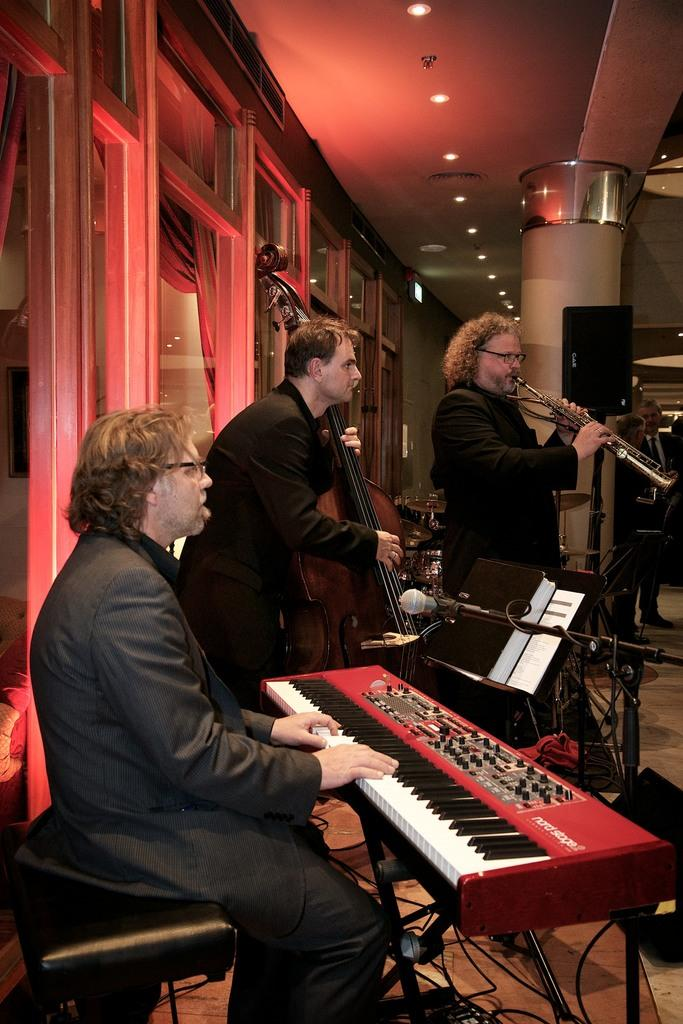How many men are in the image? There are three men in the image. What are the men doing in the image? Each of the men is holding a musical instrument. What can be seen in the background of the image? There are windows, lights on the ceiling, a speaker, and people visible in the background. What type of throne is visible in the image? There is no throne present in the image. How does the plane affect the musical performance in the image? There is no plane present in the image, so it does not affect the musical performance. 